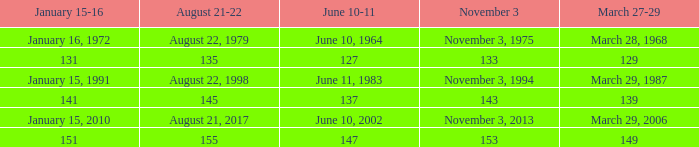What number is shown for january 15-16 when november 3 is 133? 131.0. 